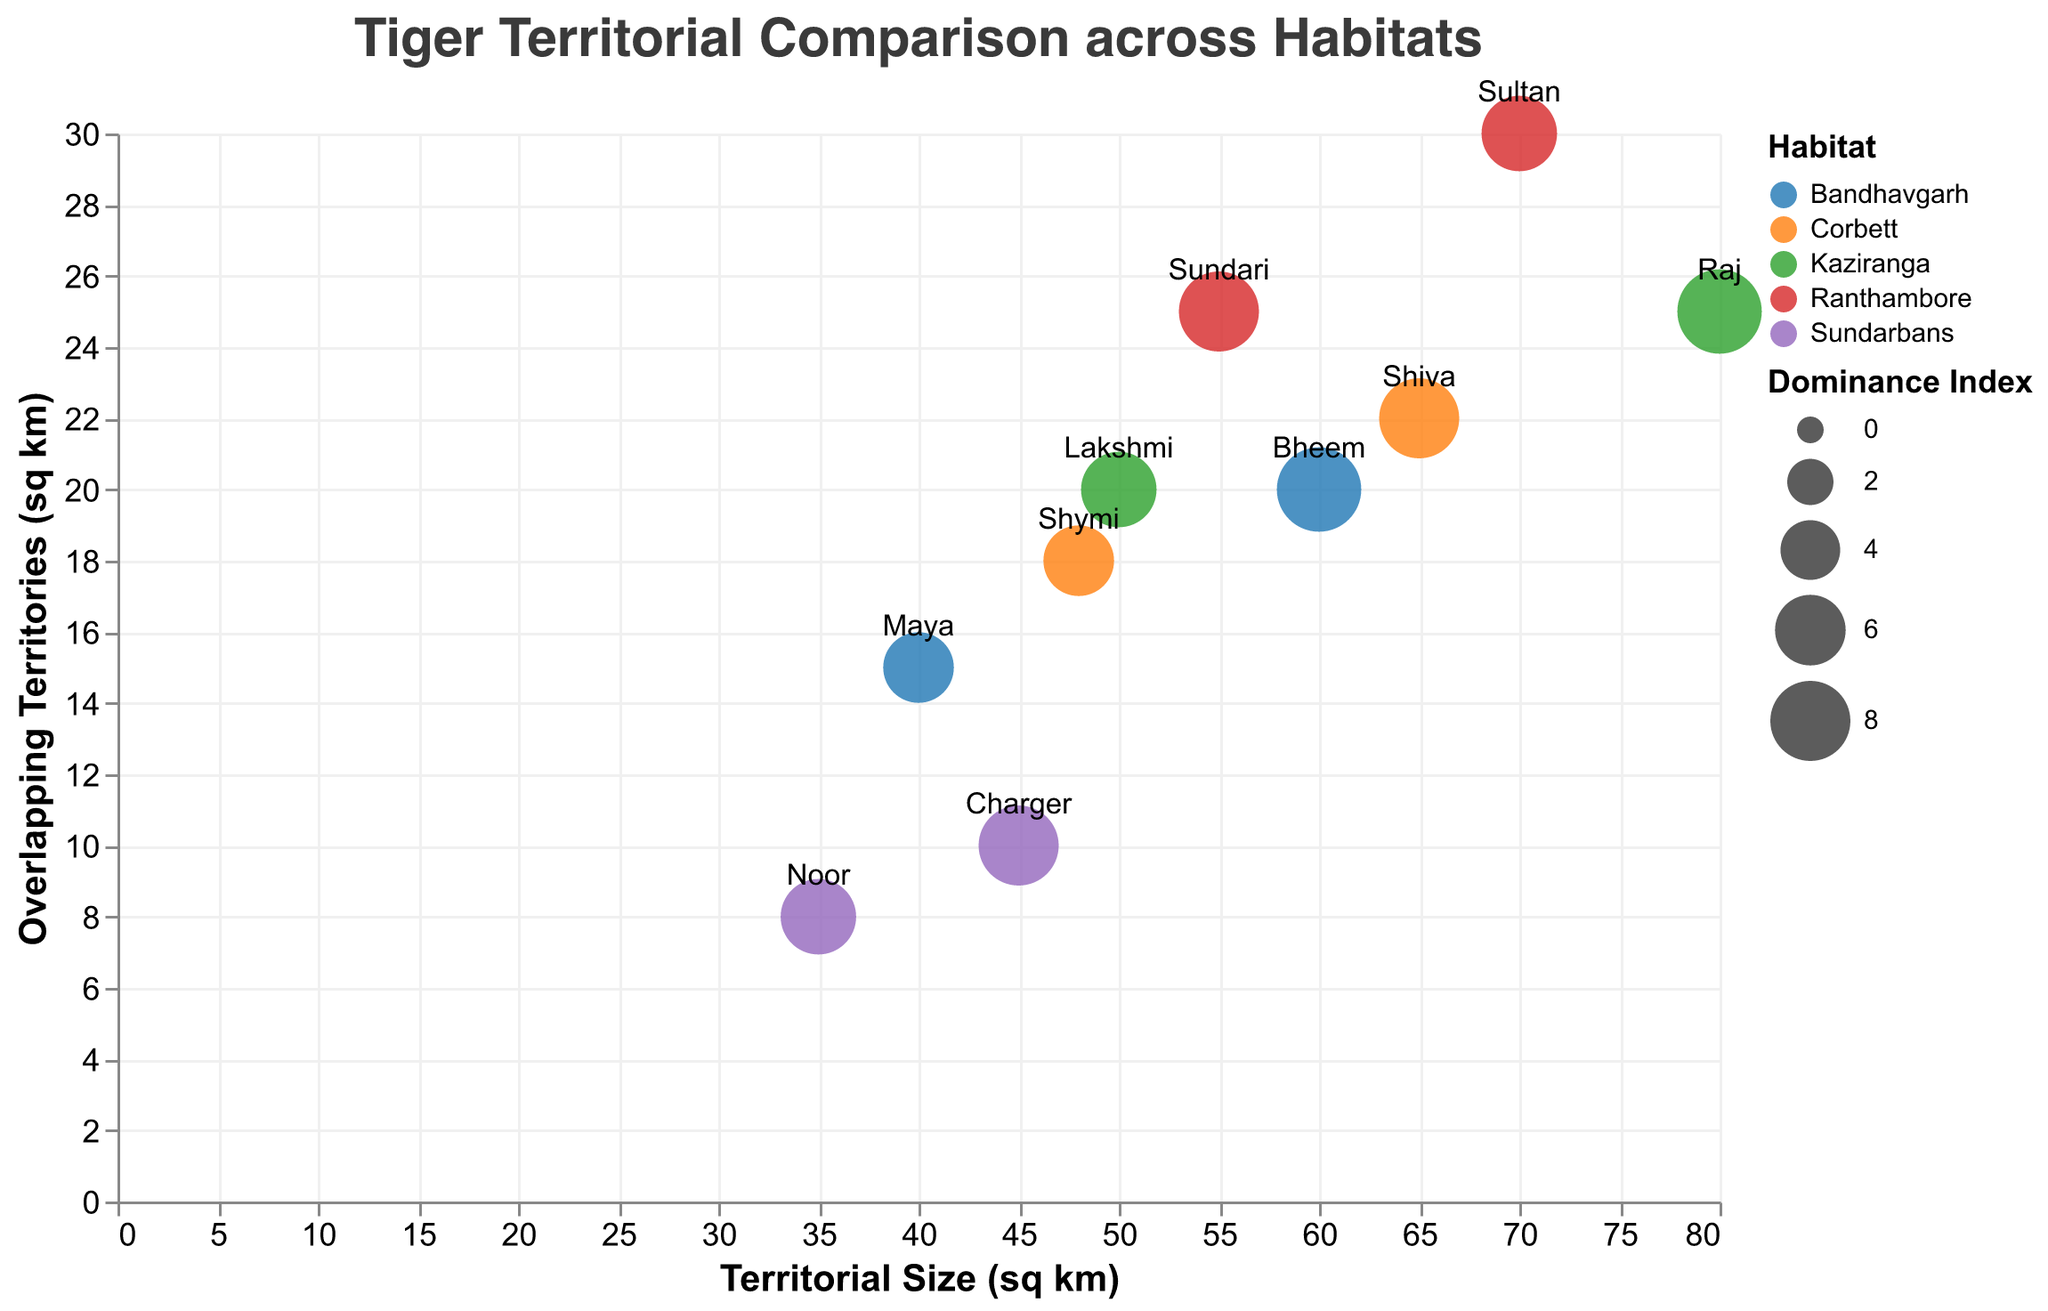How many male and female tigers are represented in the Ranthambore habitat? By looking at the plot, you can identify markers for Ranthambore habitat based on the color legend and count the shapes for each gender.
Answer: 2 males, 1 female Which tiger has the largest territorial size and what is its habitat? By examining the x-axis for the highest value and checking the corresponding tooltip, you can find the tiger's individual name and habitat.
Answer: Raj, Kaziranga Which habitat has the highest average overlapping territory for the female tigers? Identify all female tigers, sum their overlapping territories for each habitat, and then calculate the average for each habitat.
Answer: Ranthambore Comparing Sundari and Shiva, who has a higher dominance index, and by how much? Locate markers for Sundari and Shiva, check their dominance index from the tooltip, and calculate the difference.
Answer: Sundari by 1 What is the median territorial size for male tigers? Identify all male tigers and their territorial sizes, then find the middle value when these sizes are arranged in ascending order. List the values 45, 60, 65, 70, 80 and identify the median.
Answer: 65 Which gender generally has more overlapping territories in Bandhavgarh? Identify Bandhavgarh tigers, consider their genders, and compare their overlapping territories.
Answer: Male Do higher dominance indices correlate with larger territories in the figure? Examine the plot to see if larger bubbles, which indicate higher dominance indices, are generally aligned with larger x-axis values (territorial size).
Answer: Yes Are there any tigers with overlapping territories greater than 20 sq km but with a lower dominance index compared to others with similar overlaps? Search for markers with y-axis values greater than 20 and compare their dominance index to others in the same y-axis range.
Answer: Maya, compared to Raj and Sultan How does Charger’s overlapping territory in Sundarbans compare to the overlapping territories of other male tigers in different habitats? Identify Charger’s overlapping territory and compare it to the overlapping territories of male tigers in other habitats using the y-axis.
Answer: Less than Bheem, Raj, Sultan, and Shiva Which tiger has the smallest territorial size and what is its dominance index? Observe the minimum value on the x-axis to locate the smallest territorial size and check the dominance index from the tooltip.
Answer: Noor, 7 